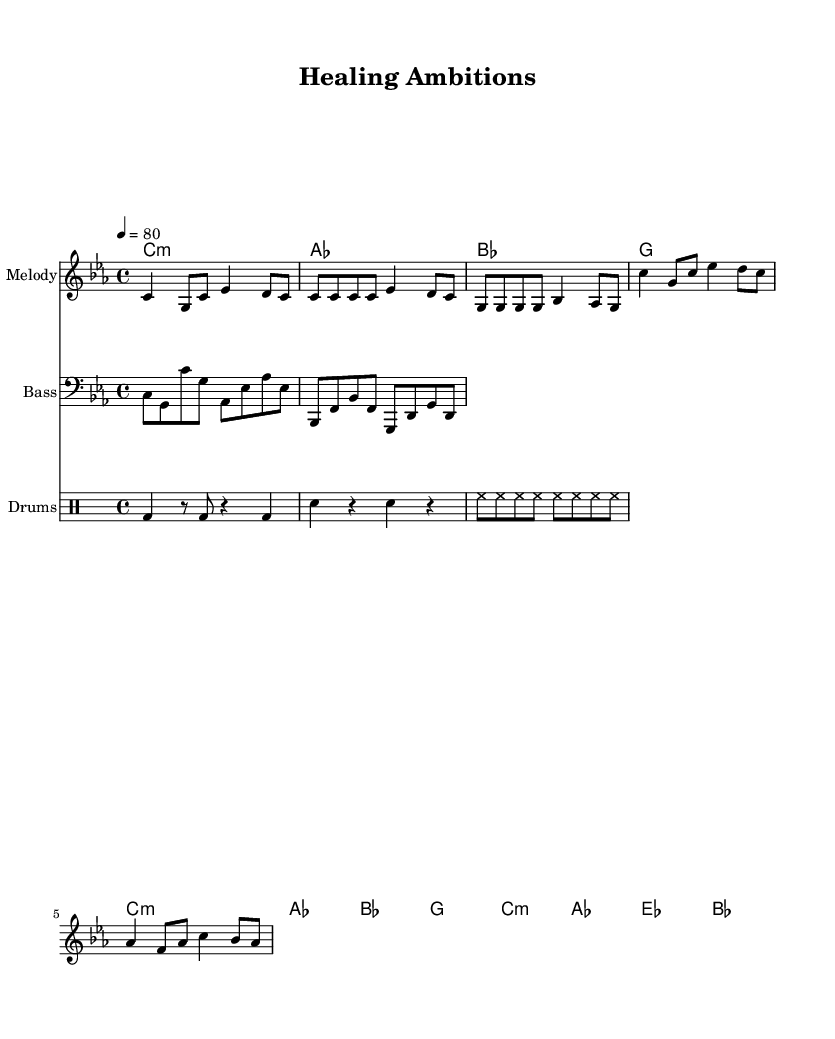What is the key signature of this music? The key signature is C minor, which has three flats (B flat, E flat, and A flat) indicated at the beginning of the staff.
Answer: C minor What is the time signature of the piece? The time signature is indicated at the beginning of the staff as 4/4, meaning there are four beats in each measure, and the quarter note gets one beat.
Answer: 4/4 What is the tempo marking for this music? The tempo marking indicated in the score says "4 = 80," which tells us that there are 80 beats per minute.
Answer: 80 How many measures are there in the melody section? Counting the measures in the melody, there are a total of 8 measures presented for the melody section.
Answer: 8 Which instruments are included in this score? The score includes three instruments: a melody instrument (likely a lead), a bass guitar, and a drum set. Each has its own staff.
Answer: Melody, Bass, Drums What is the main thematic structure of this rap piece? The thematic structure consists of an introduction, a verse, and a chorus, showcasing the typical organization in rap music for building narrative.
Answer: Intro, Verse, Chorus What harmonic progression is used in the chorus? The harmonic progression in the chorus is C minor, A flat, E flat, B flat, showing a commonly constructed sequence for emotional conveyance.
Answer: C minor, A flat, E flat, B flat 